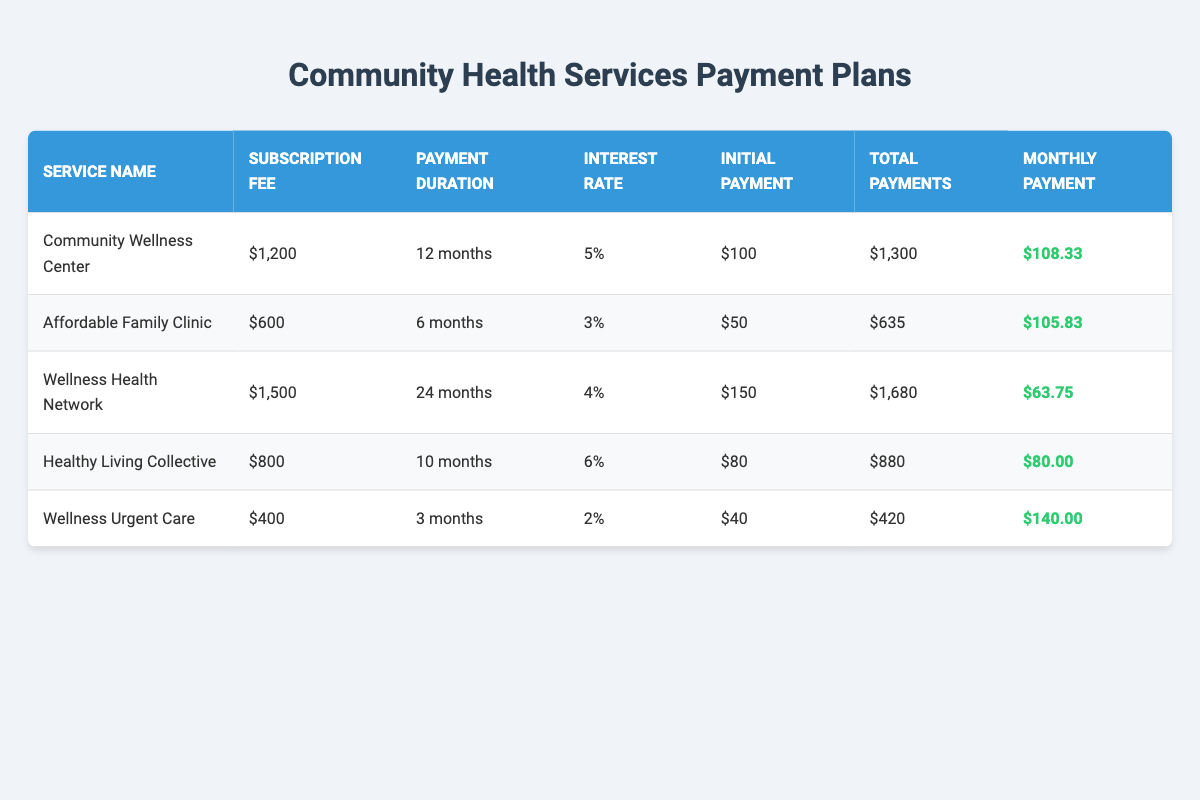What is the monthly payment for the Community Wellness Center? The table shows that the monthly payment for the Community Wellness Center is listed in the 'Monthly Payment' column. It states $108.33.
Answer: $108.33 What is the subscription fee for the Affordable Family Clinic? The table indicates that the subscription fee for the Affordable Family Clinic appears in the 'Subscription Fee' column, which is $600.
Answer: $600 How long is the payment duration for the Wellness Health Network? By looking at the 'Payment Duration' column in the row for Wellness Health Network, we can see that the payment duration is 24 months.
Answer: 24 months Which service has the lowest initial payment? To determine this, we compare the 'Initial Payment' values from all services. The lowest initial payment is $40 for the Wellness Urgent Care.
Answer: $40 What is the total amount paid for the Healthy Living Collective after the payment period? The total payments for Healthy Living Collective can be found in the 'Total Payments' column, and it shows $880.
Answer: $880 Is the interest rate for the Wellness Urgent Care higher than 3%? Checking the 'Interest Rate' column for Wellness Urgent Care reveals it is 2%, which is indeed lower than 3%. Therefore, the statement is false.
Answer: No Which service has the highest monthly payment? Compare the 'Monthly Payment' for all services. The highest monthly payment is for the Wellness Urgent Care at $140.00.
Answer: $140.00 What is the average subscription fee among all community health services? The subscription fees are $1200, $600, $1500, $800, and $400. Summing them up gives $1200 + $600 + $1500 + $800 + $400 = $3500. Then dividing by the number of services (5), the average subscription fee is $3500 / 5 = $700.
Answer: $700 How many services offer a monthly payment less than $100? Analyzing the 'Monthly Payment' column, the services with monthly payments of $63.75 (Wellness Health Network) and $80.00 (Healthy Living Collective) are less than $100. Therefore, there are 2 such services.
Answer: 2 